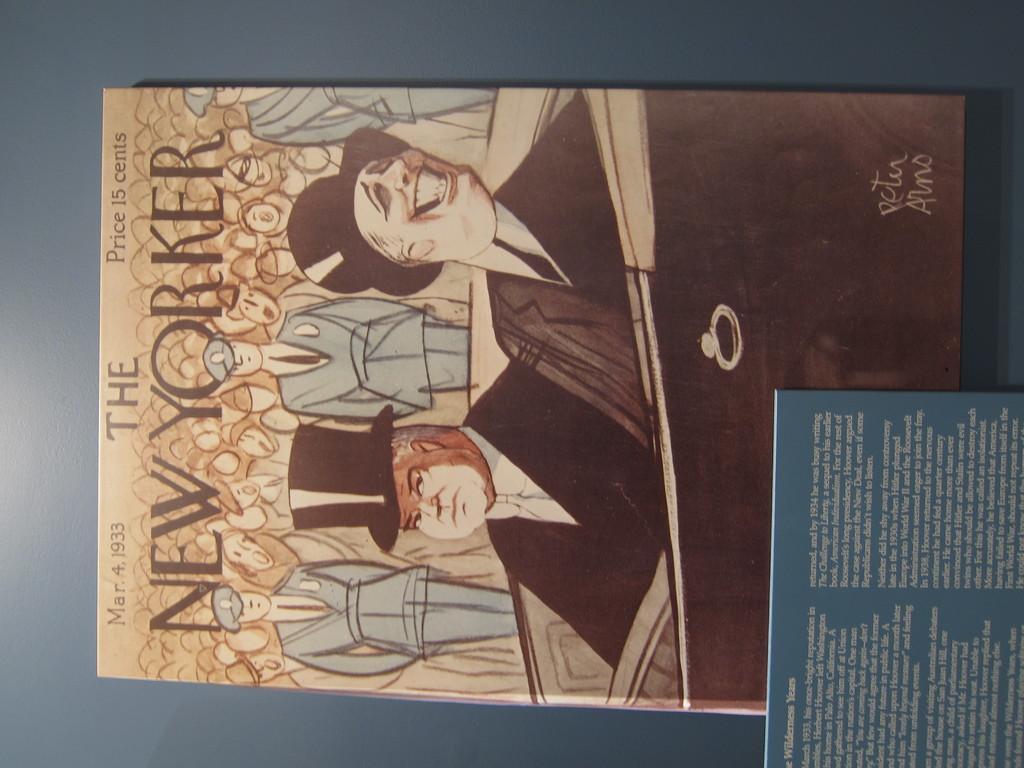Can you describe this image briefly? In this image, we can see a book contains depiction of persons and some text. There is an another book in the bottom right of the image. 